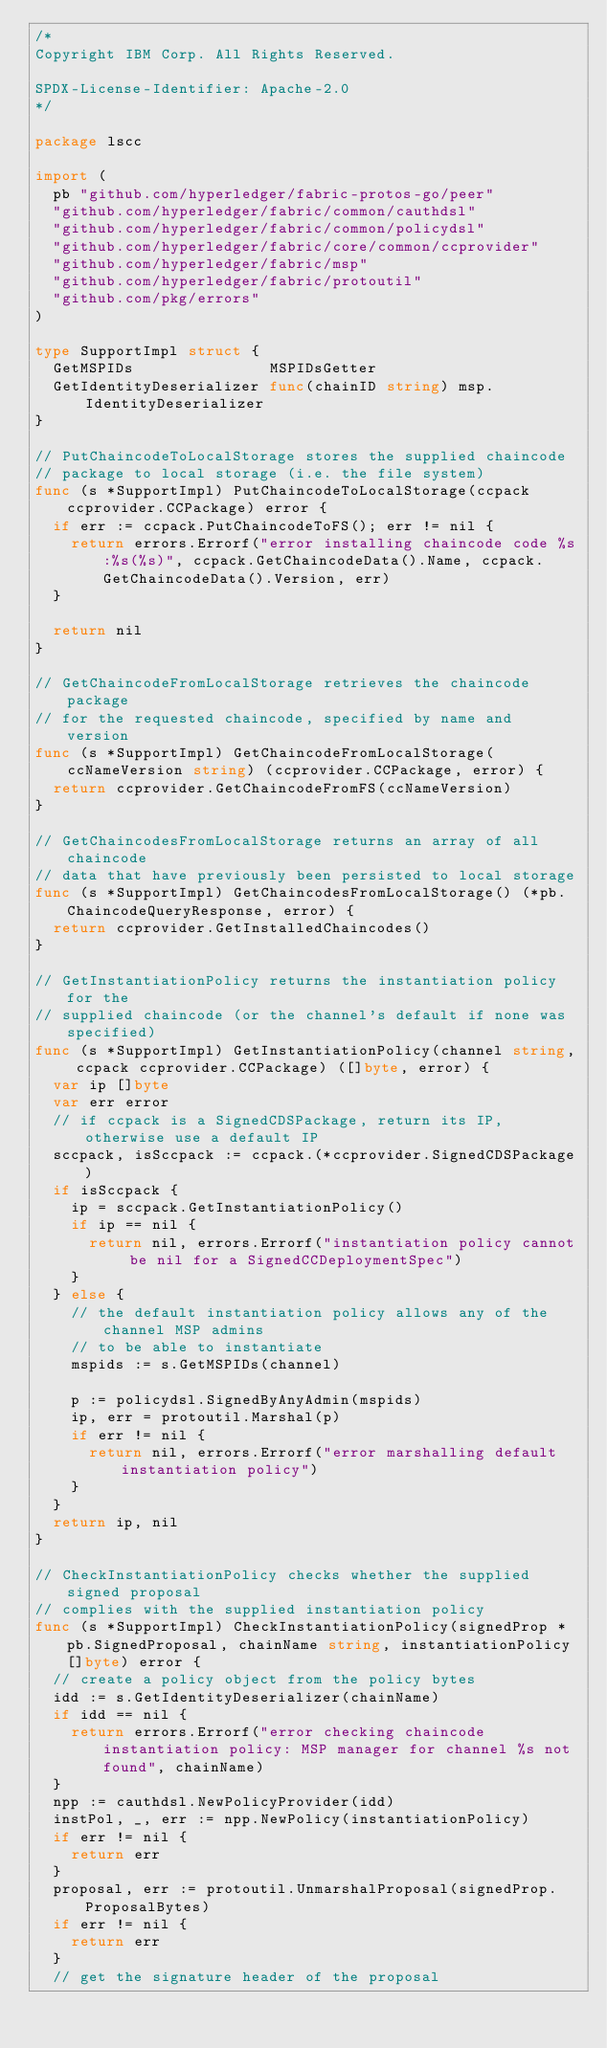<code> <loc_0><loc_0><loc_500><loc_500><_Go_>/*
Copyright IBM Corp. All Rights Reserved.

SPDX-License-Identifier: Apache-2.0
*/

package lscc

import (
	pb "github.com/hyperledger/fabric-protos-go/peer"
	"github.com/hyperledger/fabric/common/cauthdsl"
	"github.com/hyperledger/fabric/common/policydsl"
	"github.com/hyperledger/fabric/core/common/ccprovider"
	"github.com/hyperledger/fabric/msp"
	"github.com/hyperledger/fabric/protoutil"
	"github.com/pkg/errors"
)

type SupportImpl struct {
	GetMSPIDs               MSPIDsGetter
	GetIdentityDeserializer func(chainID string) msp.IdentityDeserializer
}

// PutChaincodeToLocalStorage stores the supplied chaincode
// package to local storage (i.e. the file system)
func (s *SupportImpl) PutChaincodeToLocalStorage(ccpack ccprovider.CCPackage) error {
	if err := ccpack.PutChaincodeToFS(); err != nil {
		return errors.Errorf("error installing chaincode code %s:%s(%s)", ccpack.GetChaincodeData().Name, ccpack.GetChaincodeData().Version, err)
	}

	return nil
}

// GetChaincodeFromLocalStorage retrieves the chaincode package
// for the requested chaincode, specified by name and version
func (s *SupportImpl) GetChaincodeFromLocalStorage(ccNameVersion string) (ccprovider.CCPackage, error) {
	return ccprovider.GetChaincodeFromFS(ccNameVersion)
}

// GetChaincodesFromLocalStorage returns an array of all chaincode
// data that have previously been persisted to local storage
func (s *SupportImpl) GetChaincodesFromLocalStorage() (*pb.ChaincodeQueryResponse, error) {
	return ccprovider.GetInstalledChaincodes()
}

// GetInstantiationPolicy returns the instantiation policy for the
// supplied chaincode (or the channel's default if none was specified)
func (s *SupportImpl) GetInstantiationPolicy(channel string, ccpack ccprovider.CCPackage) ([]byte, error) {
	var ip []byte
	var err error
	// if ccpack is a SignedCDSPackage, return its IP, otherwise use a default IP
	sccpack, isSccpack := ccpack.(*ccprovider.SignedCDSPackage)
	if isSccpack {
		ip = sccpack.GetInstantiationPolicy()
		if ip == nil {
			return nil, errors.Errorf("instantiation policy cannot be nil for a SignedCCDeploymentSpec")
		}
	} else {
		// the default instantiation policy allows any of the channel MSP admins
		// to be able to instantiate
		mspids := s.GetMSPIDs(channel)

		p := policydsl.SignedByAnyAdmin(mspids)
		ip, err = protoutil.Marshal(p)
		if err != nil {
			return nil, errors.Errorf("error marshalling default instantiation policy")
		}
	}
	return ip, nil
}

// CheckInstantiationPolicy checks whether the supplied signed proposal
// complies with the supplied instantiation policy
func (s *SupportImpl) CheckInstantiationPolicy(signedProp *pb.SignedProposal, chainName string, instantiationPolicy []byte) error {
	// create a policy object from the policy bytes
	idd := s.GetIdentityDeserializer(chainName)
	if idd == nil {
		return errors.Errorf("error checking chaincode instantiation policy: MSP manager for channel %s not found", chainName)
	}
	npp := cauthdsl.NewPolicyProvider(idd)
	instPol, _, err := npp.NewPolicy(instantiationPolicy)
	if err != nil {
		return err
	}
	proposal, err := protoutil.UnmarshalProposal(signedProp.ProposalBytes)
	if err != nil {
		return err
	}
	// get the signature header of the proposal</code> 